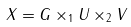Convert formula to latex. <formula><loc_0><loc_0><loc_500><loc_500>X = G \times _ { 1 } U \times _ { 2 } V</formula> 